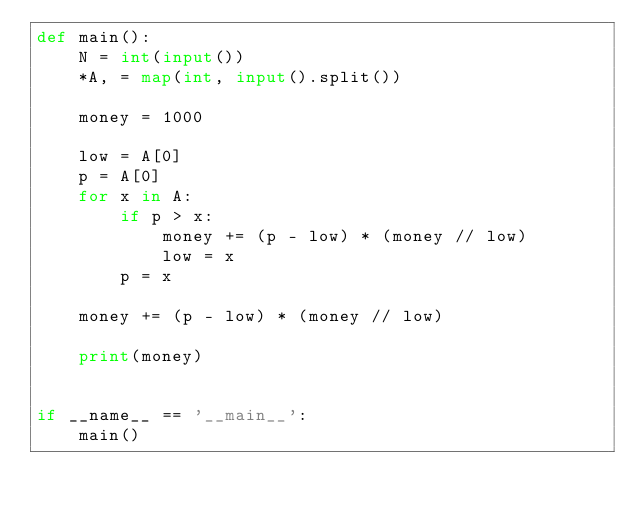Convert code to text. <code><loc_0><loc_0><loc_500><loc_500><_Python_>def main():
    N = int(input())
    *A, = map(int, input().split())

    money = 1000

    low = A[0]
    p = A[0]
    for x in A:
        if p > x:
            money += (p - low) * (money // low)
            low = x
        p = x

    money += (p - low) * (money // low)

    print(money)


if __name__ == '__main__':
    main()
</code> 